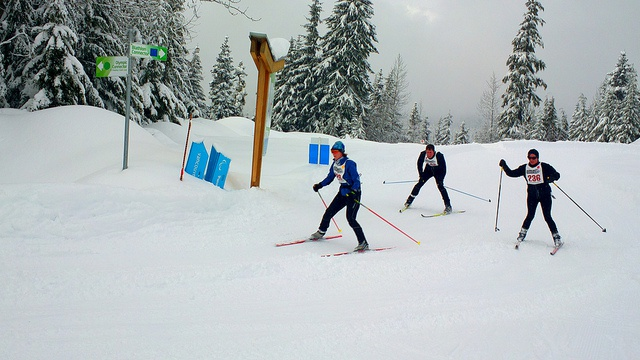Describe the objects in this image and their specific colors. I can see people in black, navy, lightgray, and gray tones, people in black, lightgray, darkgray, and gray tones, people in black, gray, darkgray, and maroon tones, skis in black, lightgray, darkgray, lightpink, and brown tones, and skis in black, darkgray, lightgray, tan, and olive tones in this image. 